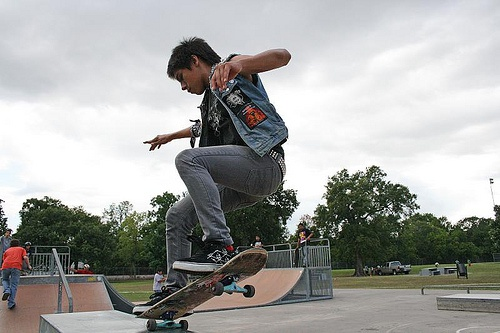Describe the objects in this image and their specific colors. I can see people in lightgray, black, gray, white, and darkgray tones, skateboard in lightgray, black, and gray tones, people in lightgray, black, gray, brown, and darkblue tones, people in lightgray, black, gray, maroon, and darkgray tones, and truck in lightgray, black, gray, and darkgray tones in this image. 